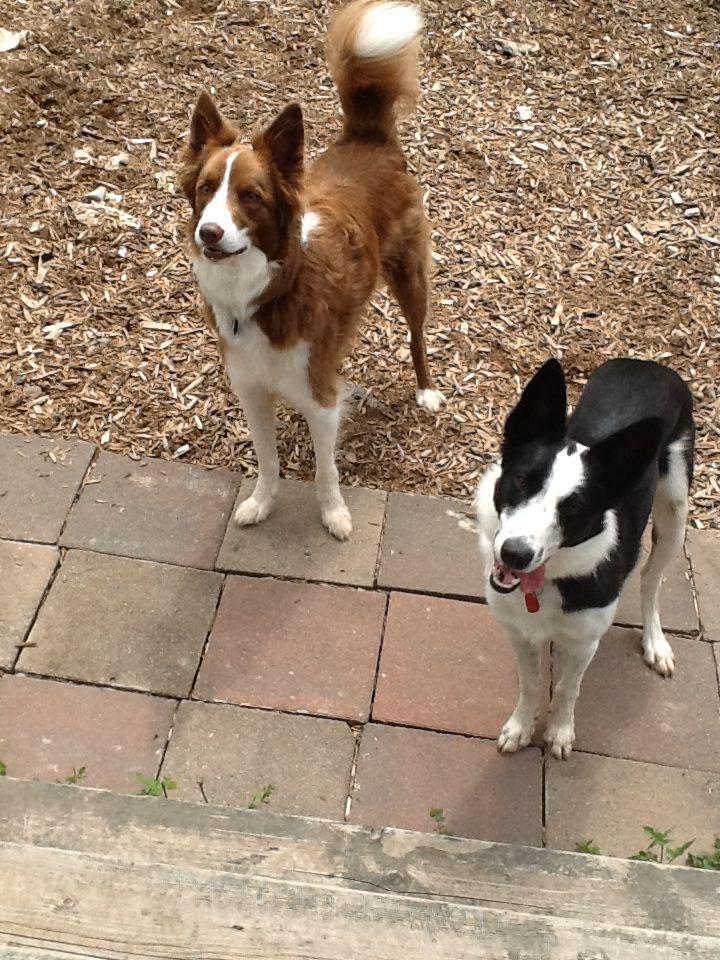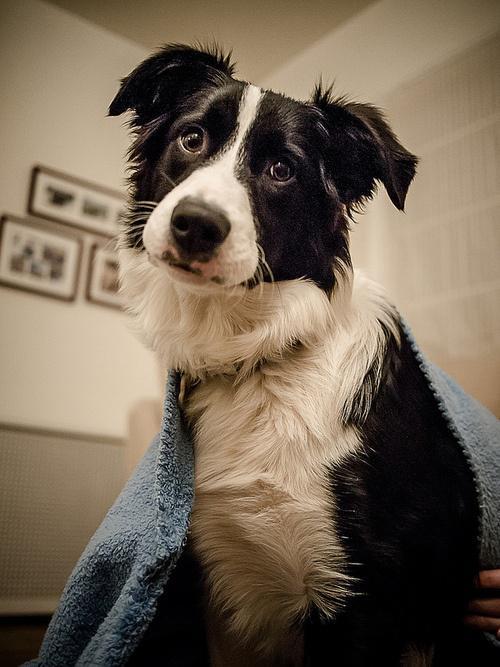The first image is the image on the left, the second image is the image on the right. Considering the images on both sides, is "In one image, a black and white dog is outdoors with sheep." valid? Answer yes or no. No. The first image is the image on the left, the second image is the image on the right. Evaluate the accuracy of this statement regarding the images: "Right image contains one dog sitting up.". Is it true? Answer yes or no. Yes. 